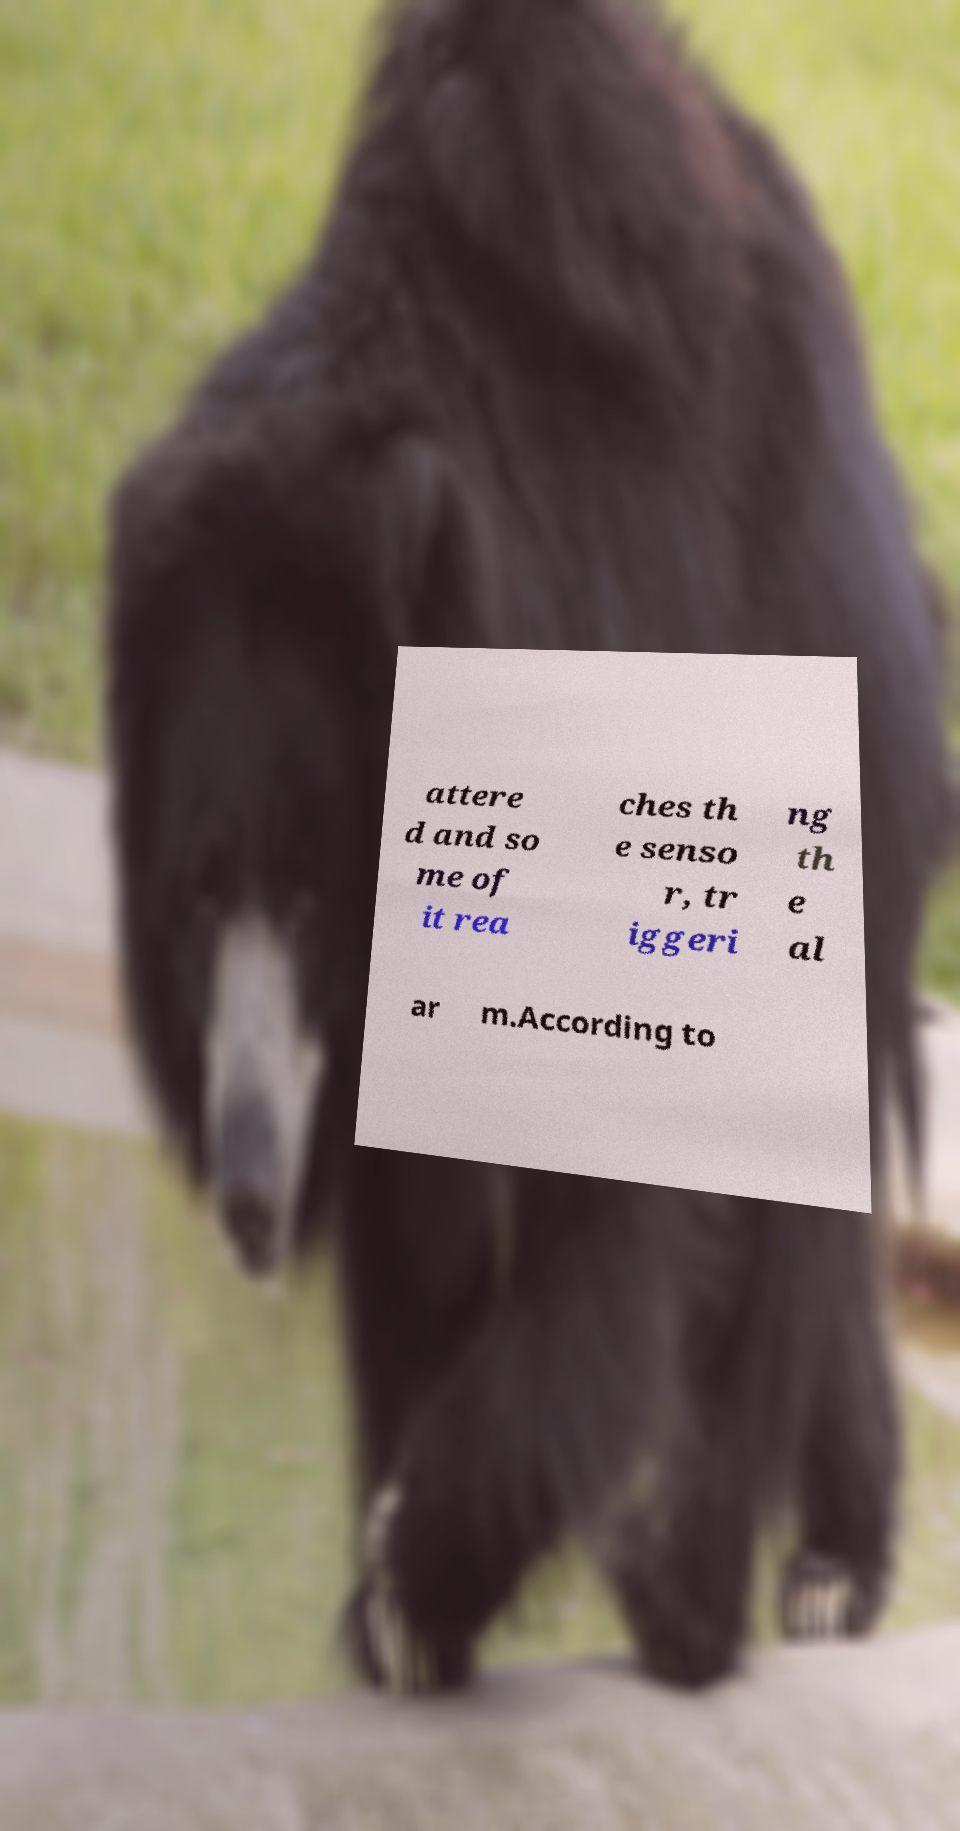Can you read and provide the text displayed in the image?This photo seems to have some interesting text. Can you extract and type it out for me? attere d and so me of it rea ches th e senso r, tr iggeri ng th e al ar m.According to 